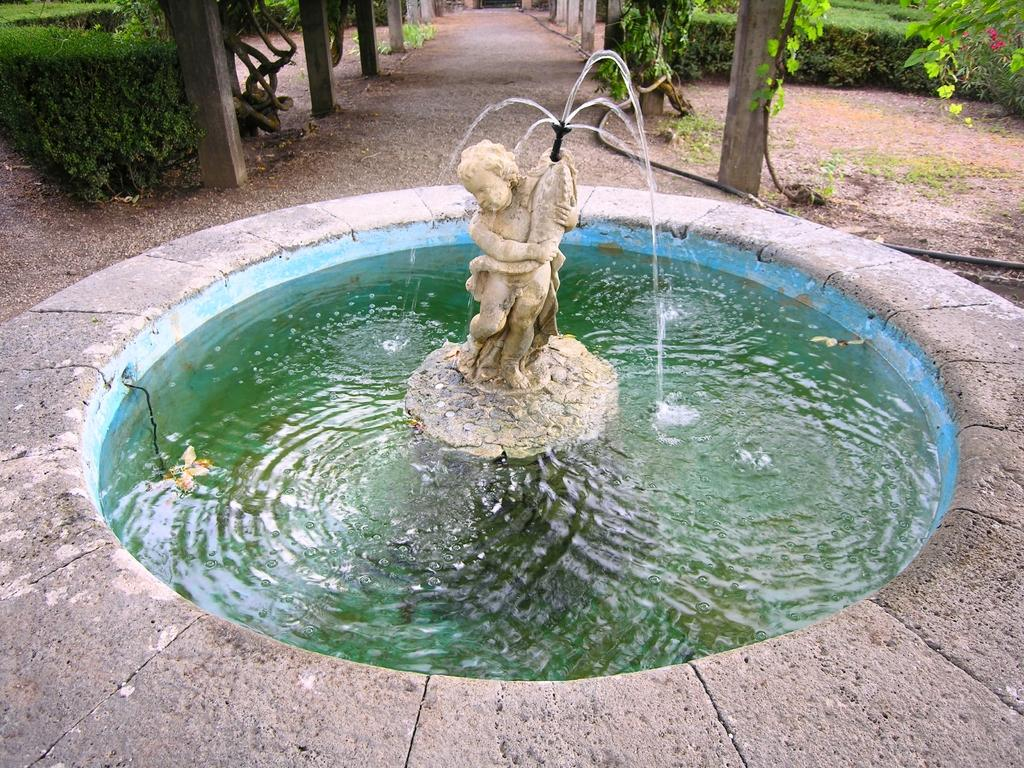What is the main subject in the image? There is a statue in the image. What other feature can be seen in the image? There is a fountain in the image. What can be seen in the background of the image? There are trees in the background of the image. What type of drum can be heard playing in the background of the image? There is no drum or sound present in the image; it is a visual representation of a statue and a fountain with trees in the background. 